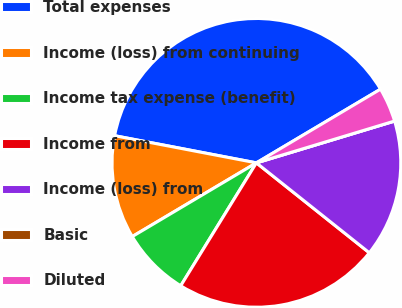Convert chart. <chart><loc_0><loc_0><loc_500><loc_500><pie_chart><fcel>Total expenses<fcel>Income (loss) from continuing<fcel>Income tax expense (benefit)<fcel>Income from<fcel>Income (loss) from<fcel>Basic<fcel>Diluted<nl><fcel>38.46%<fcel>11.54%<fcel>7.69%<fcel>23.08%<fcel>15.38%<fcel>0.0%<fcel>3.85%<nl></chart> 